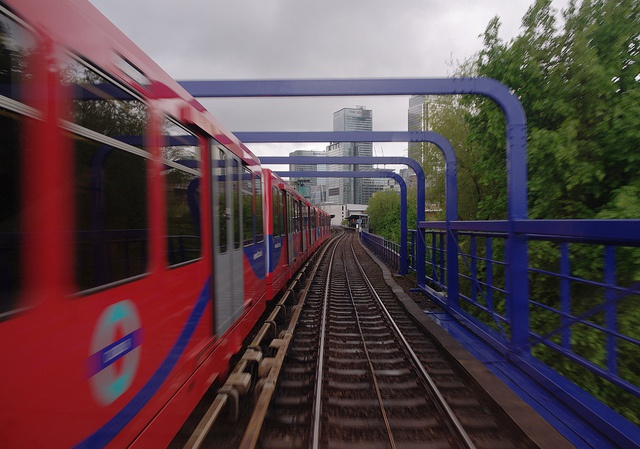Describe the objects in this image and their specific colors. I can see a train in black, maroon, and gray tones in this image. 